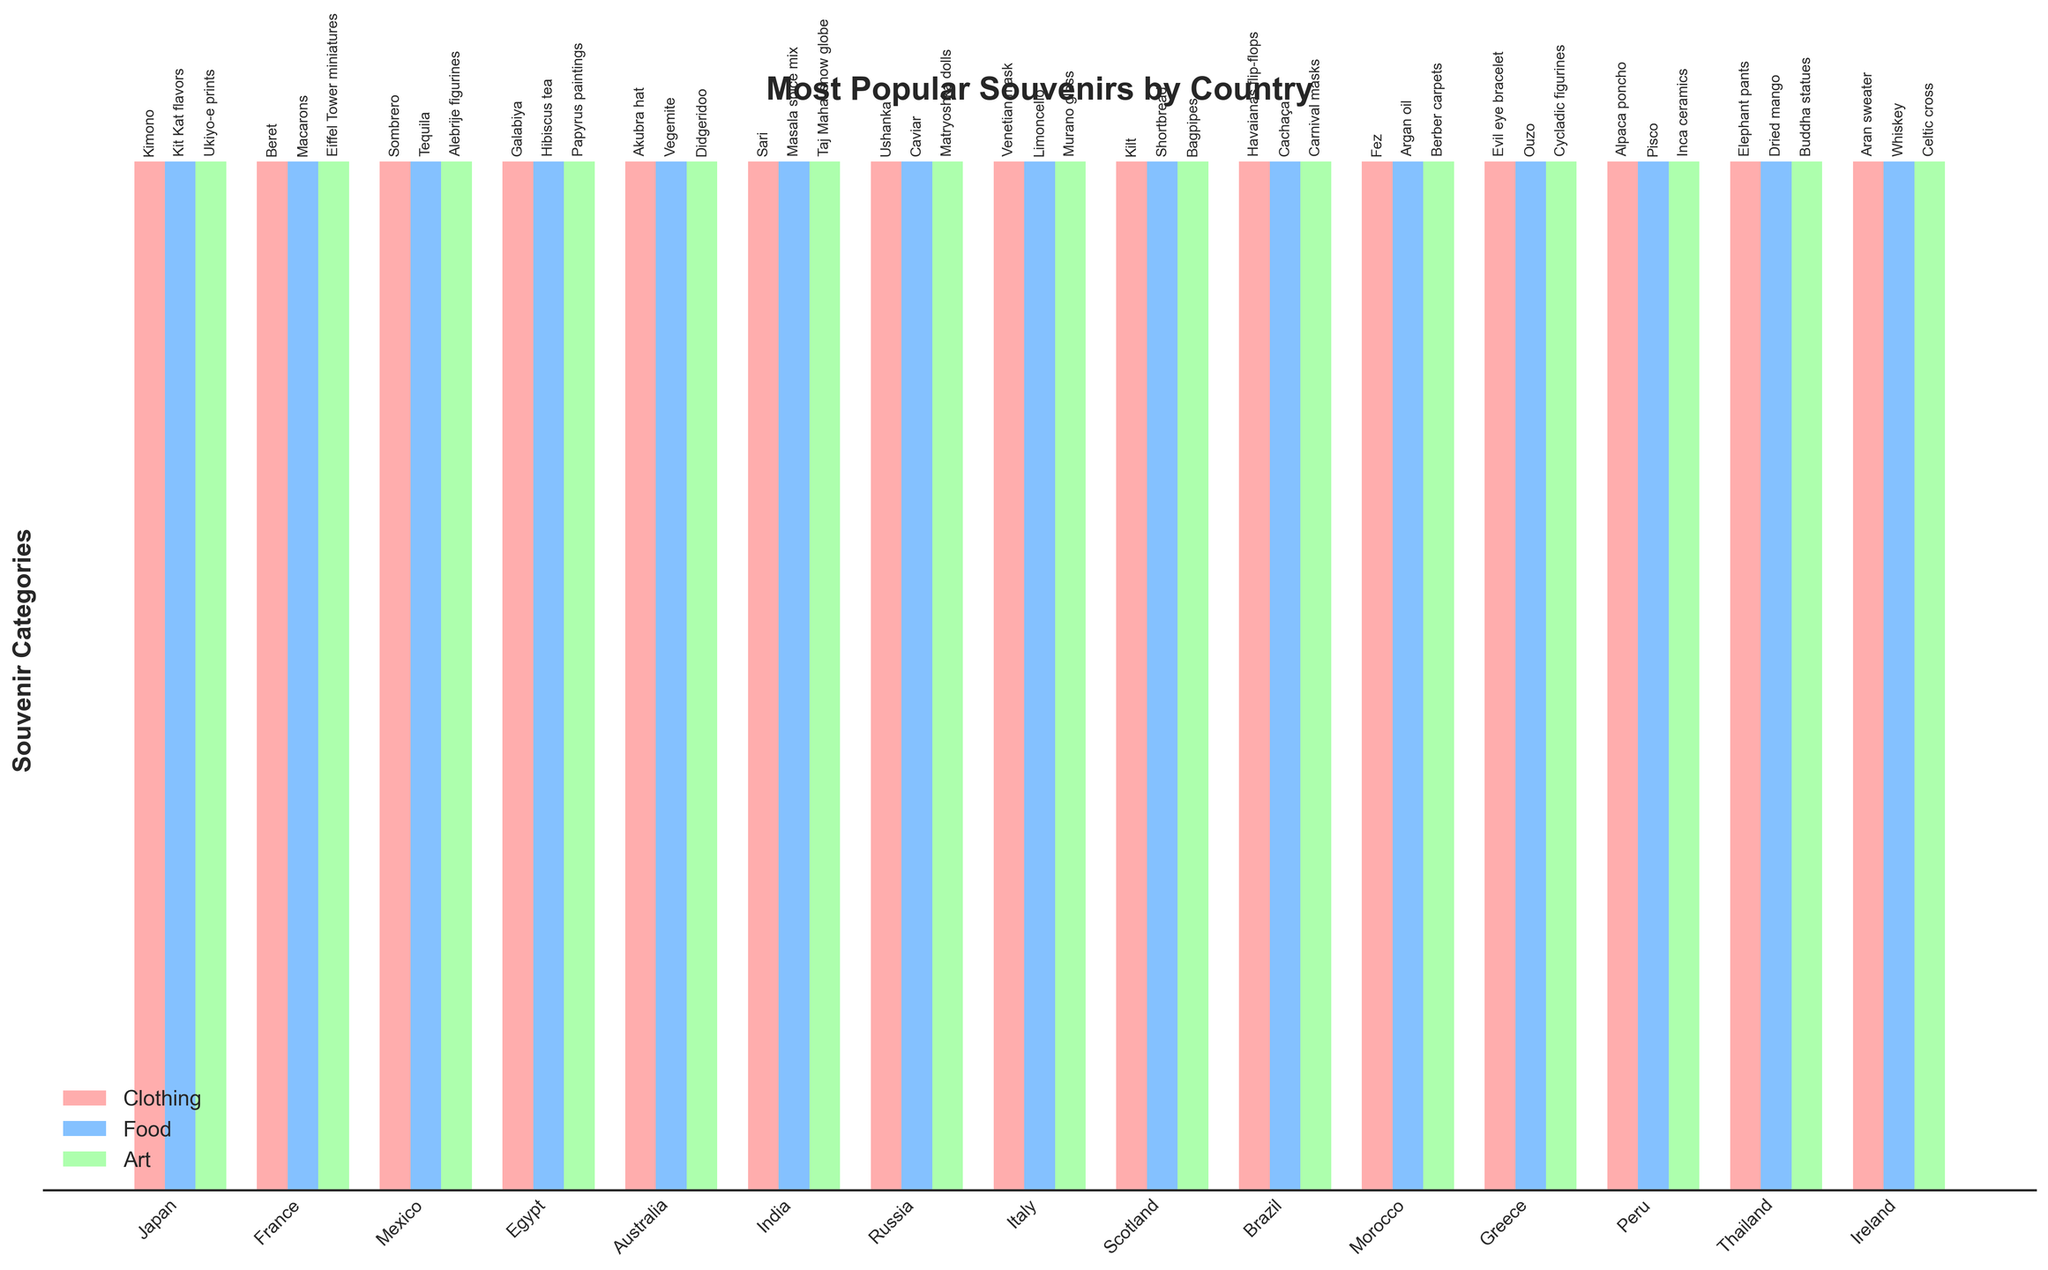Which country has 'Kimono' as its most popular clothing souvenir? Look at the bar labeled 'Clothing'. The autolabel shows which souvenir is from which country.
Answer: Japan Which countries have food souvenirs related to alcoholic drinks? Find the bars labeled 'Food' and check for autolabels indicating alcoholic drinks.
Answer: Mexico, Italy, Greece, Ireland, Brazil, Peru, Russia Which country has the tallest bar for Food category, labeled with 'Macarons'? Identify the Food bars and look for the one with the label 'Macarons'.
Answer: France What is the common characteristic among souvenirs in the 'Art' category for countries in South America? Look at the labels within the 'Art' bars for countries like Brazil and Peru. Both should share a cultural or thematic similarity.
Answer: They are traditional and culturally significant artifacts Compare the most popular art souvenirs between Egypt and Greece. What are they? Check the autolabels in the 'Art' category for both countries.
Answer: Papyrus paintings (Egypt) and Cycladic figurines (Greece) Identify the country whose most popular food souvenir is 'Kit Kat flavors'. Is this country from Asia or Europe? Find the autolabel 'Kit Kat flavors' under the 'Food' category and check its country.
Answer: Japan, Asia How many souvenirs in the 'Clothing' category are types of hats? Count the clothing souvenirs labeled as hats across all countries.
Answer: 4 (Beret, Sombrero, Akubra hat, Ushanka) Which country’s most popular art souvenir is a musical instrument, according to the visual attributes? Look for a label indicating a musical instrument in the 'Art' category bars.
Answer: Scotland (Bagpipes) What is the difference between the types of souvenirs marked as 'Food' for France and Australia? Compare their 'Food' labels. France has 'Macarons' and Australia has 'Vegemite'; one is a confectionery food and the other is a spread.
Answer: Macarons (confectionery) vs Vegemite (spread) What’s the relationship between the labels on the 'Art' category for Italy and the 'Art' category for Mexico? Compare the autolabels in the 'Art' category for these countries and note any historical or cultural aspects.
Answer: Both reflect traditional craftsmanship: Murano glass (Italy) and Alebrije figurines (Mexico) 